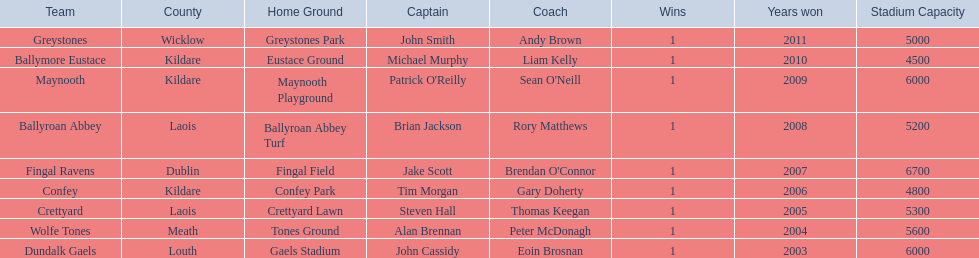What is the number of wins for each team 1. 